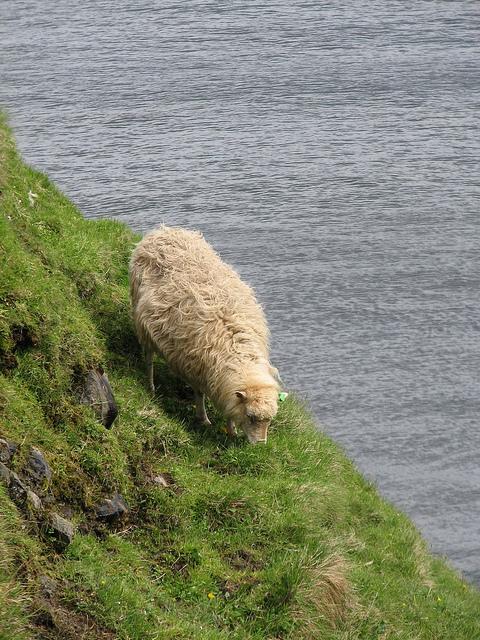What kind of animal is this?
Keep it brief. Sheep. Would you say this is a tropical environment?
Write a very short answer. No. What objects are in the grass?
Short answer required. Rocks. How many legs does the animal have?
Be succinct. 4. 